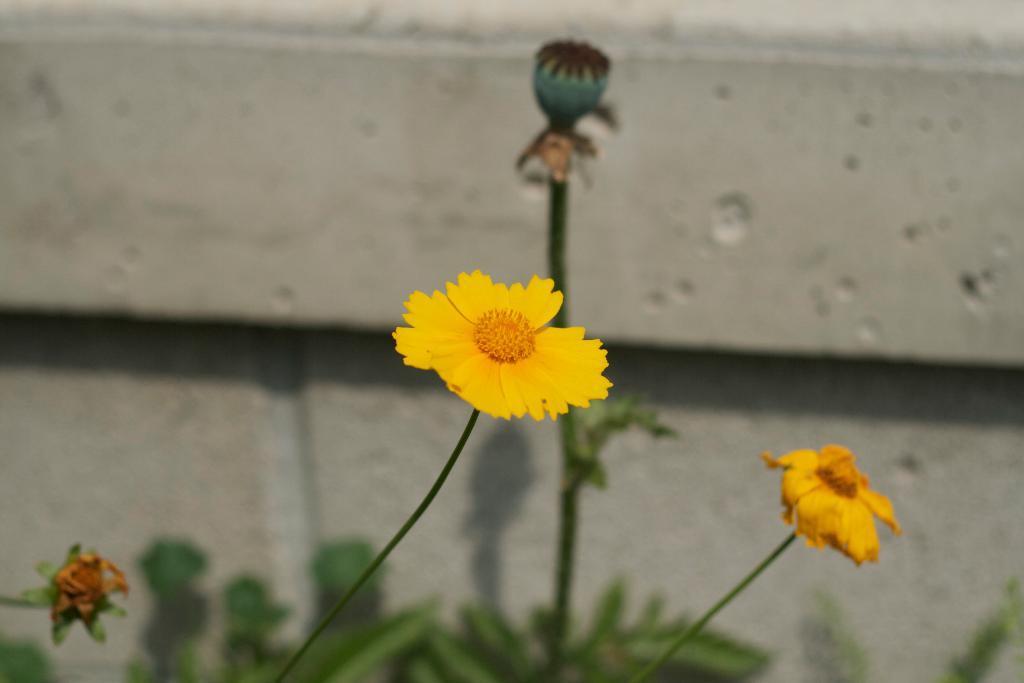Please provide a concise description of this image. In this image I can see some yellow color flowers, buds and leaves of the plant. I can see a wall behind the plants and the background is blurred. 